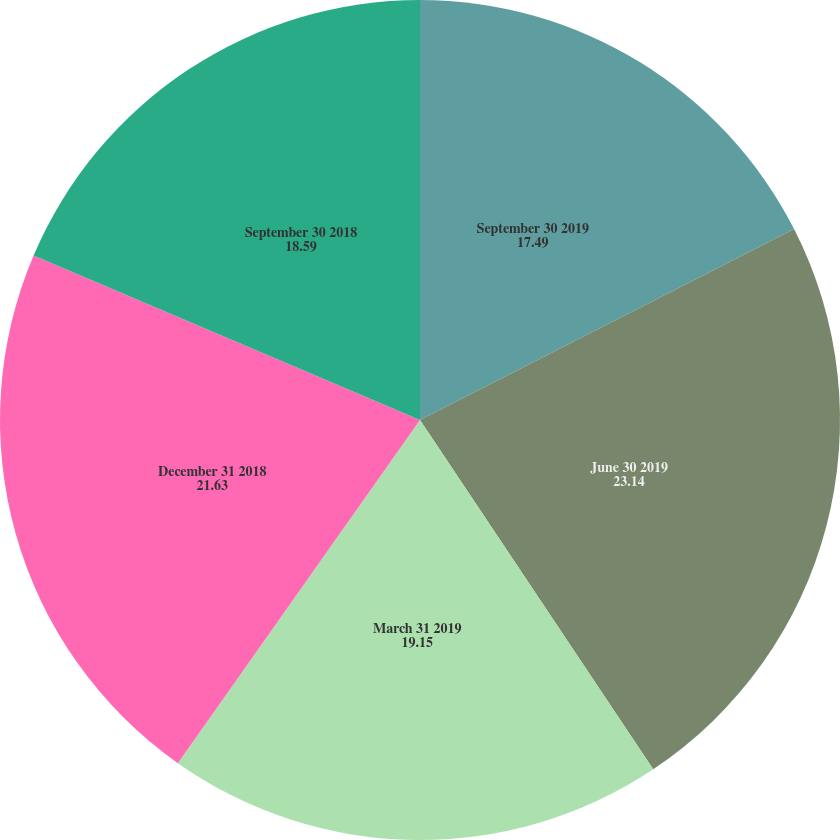Convert chart to OTSL. <chart><loc_0><loc_0><loc_500><loc_500><pie_chart><fcel>September 30 2019<fcel>June 30 2019<fcel>March 31 2019<fcel>December 31 2018<fcel>September 30 2018<nl><fcel>17.49%<fcel>23.14%<fcel>19.15%<fcel>21.63%<fcel>18.59%<nl></chart> 